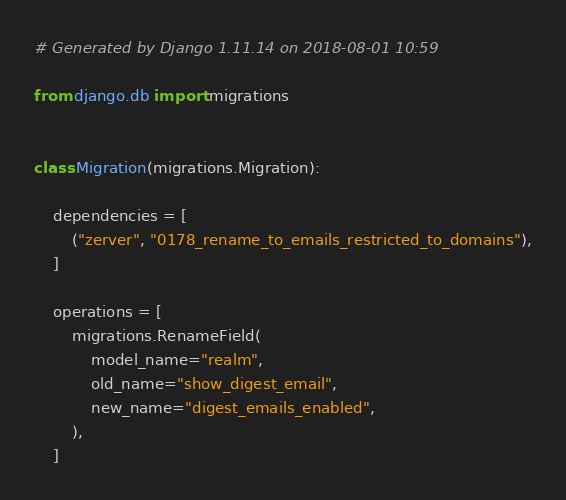Convert code to text. <code><loc_0><loc_0><loc_500><loc_500><_Python_># Generated by Django 1.11.14 on 2018-08-01 10:59

from django.db import migrations


class Migration(migrations.Migration):

    dependencies = [
        ("zerver", "0178_rename_to_emails_restricted_to_domains"),
    ]

    operations = [
        migrations.RenameField(
            model_name="realm",
            old_name="show_digest_email",
            new_name="digest_emails_enabled",
        ),
    ]
</code> 